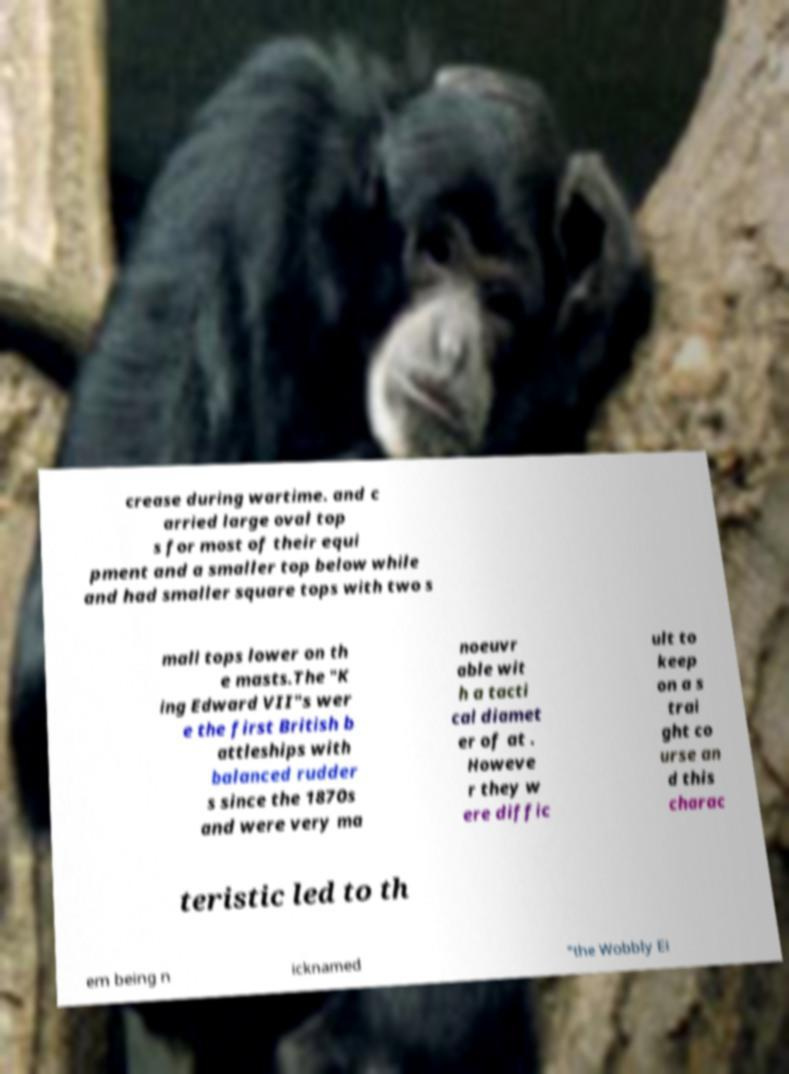Please identify and transcribe the text found in this image. crease during wartime. and c arried large oval top s for most of their equi pment and a smaller top below while and had smaller square tops with two s mall tops lower on th e masts.The "K ing Edward VII"s wer e the first British b attleships with balanced rudder s since the 1870s and were very ma noeuvr able wit h a tacti cal diamet er of at . Howeve r they w ere diffic ult to keep on a s trai ght co urse an d this charac teristic led to th em being n icknamed "the Wobbly Ei 